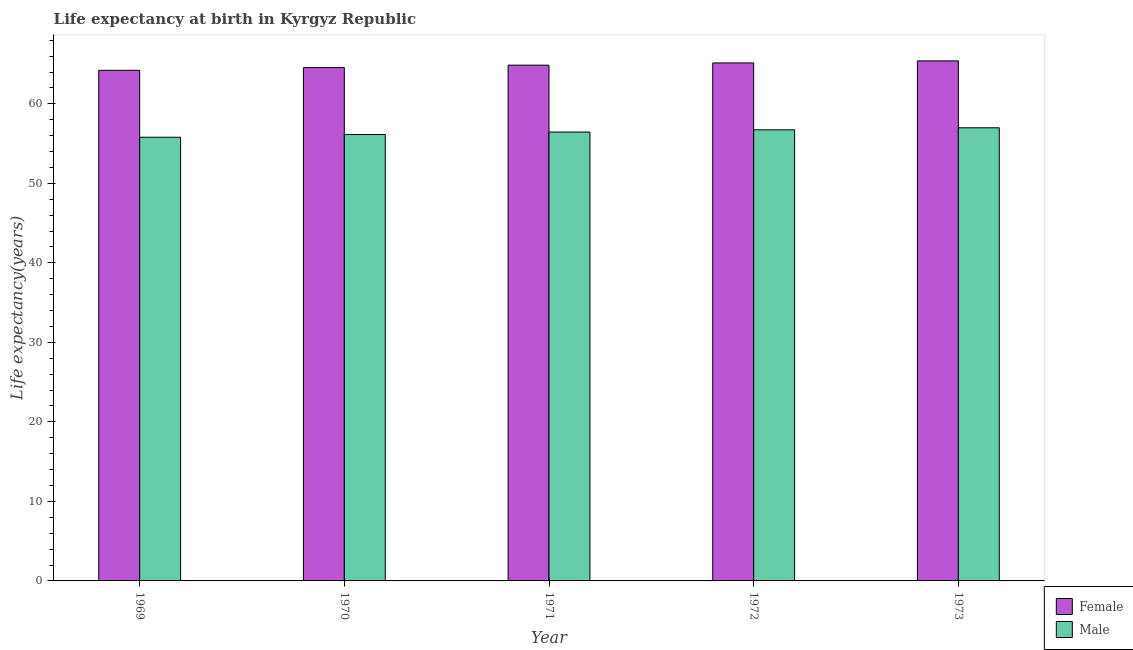Are the number of bars per tick equal to the number of legend labels?
Your response must be concise. Yes. How many bars are there on the 1st tick from the right?
Your answer should be compact. 2. What is the label of the 1st group of bars from the left?
Keep it short and to the point. 1969. What is the life expectancy(female) in 1969?
Offer a very short reply. 64.21. Across all years, what is the maximum life expectancy(male)?
Offer a very short reply. 56.99. Across all years, what is the minimum life expectancy(male)?
Make the answer very short. 55.8. In which year was the life expectancy(male) maximum?
Offer a very short reply. 1973. In which year was the life expectancy(male) minimum?
Provide a succinct answer. 1969. What is the total life expectancy(male) in the graph?
Offer a terse response. 282.11. What is the difference between the life expectancy(male) in 1971 and that in 1972?
Give a very brief answer. -0.28. What is the difference between the life expectancy(male) in 1971 and the life expectancy(female) in 1970?
Offer a very short reply. 0.31. What is the average life expectancy(female) per year?
Offer a terse response. 64.84. In the year 1973, what is the difference between the life expectancy(male) and life expectancy(female)?
Keep it short and to the point. 0. What is the ratio of the life expectancy(female) in 1971 to that in 1972?
Your answer should be very brief. 1. Is the life expectancy(male) in 1971 less than that in 1972?
Your answer should be very brief. Yes. What is the difference between the highest and the second highest life expectancy(female)?
Your answer should be very brief. 0.26. What is the difference between the highest and the lowest life expectancy(male)?
Provide a succinct answer. 1.19. Is the sum of the life expectancy(male) in 1969 and 1973 greater than the maximum life expectancy(female) across all years?
Provide a short and direct response. Yes. Are all the bars in the graph horizontal?
Your response must be concise. No. Does the graph contain grids?
Your answer should be compact. No. Where does the legend appear in the graph?
Ensure brevity in your answer.  Bottom right. How are the legend labels stacked?
Make the answer very short. Vertical. What is the title of the graph?
Offer a very short reply. Life expectancy at birth in Kyrgyz Republic. Does "Drinking water services" appear as one of the legend labels in the graph?
Provide a short and direct response. No. What is the label or title of the X-axis?
Your response must be concise. Year. What is the label or title of the Y-axis?
Your answer should be very brief. Life expectancy(years). What is the Life expectancy(years) in Female in 1969?
Your answer should be compact. 64.21. What is the Life expectancy(years) of Male in 1969?
Offer a terse response. 55.8. What is the Life expectancy(years) of Female in 1970?
Offer a very short reply. 64.55. What is the Life expectancy(years) in Male in 1970?
Your response must be concise. 56.14. What is the Life expectancy(years) in Female in 1971?
Offer a very short reply. 64.86. What is the Life expectancy(years) in Male in 1971?
Your response must be concise. 56.45. What is the Life expectancy(years) in Female in 1972?
Provide a succinct answer. 65.14. What is the Life expectancy(years) of Male in 1972?
Provide a succinct answer. 56.73. What is the Life expectancy(years) in Female in 1973?
Keep it short and to the point. 65.4. What is the Life expectancy(years) in Male in 1973?
Provide a succinct answer. 56.99. Across all years, what is the maximum Life expectancy(years) in Female?
Offer a terse response. 65.4. Across all years, what is the maximum Life expectancy(years) in Male?
Offer a very short reply. 56.99. Across all years, what is the minimum Life expectancy(years) in Female?
Offer a very short reply. 64.21. Across all years, what is the minimum Life expectancy(years) in Male?
Ensure brevity in your answer.  55.8. What is the total Life expectancy(years) of Female in the graph?
Keep it short and to the point. 324.18. What is the total Life expectancy(years) of Male in the graph?
Provide a short and direct response. 282.11. What is the difference between the Life expectancy(years) of Female in 1969 and that in 1970?
Make the answer very short. -0.34. What is the difference between the Life expectancy(years) in Male in 1969 and that in 1970?
Provide a succinct answer. -0.34. What is the difference between the Life expectancy(years) of Female in 1969 and that in 1971?
Your response must be concise. -0.65. What is the difference between the Life expectancy(years) of Male in 1969 and that in 1971?
Your answer should be very brief. -0.65. What is the difference between the Life expectancy(years) in Female in 1969 and that in 1972?
Ensure brevity in your answer.  -0.93. What is the difference between the Life expectancy(years) of Male in 1969 and that in 1972?
Offer a terse response. -0.93. What is the difference between the Life expectancy(years) in Female in 1969 and that in 1973?
Keep it short and to the point. -1.19. What is the difference between the Life expectancy(years) of Male in 1969 and that in 1973?
Your answer should be very brief. -1.19. What is the difference between the Life expectancy(years) of Female in 1970 and that in 1971?
Your response must be concise. -0.31. What is the difference between the Life expectancy(years) of Male in 1970 and that in 1971?
Your answer should be compact. -0.31. What is the difference between the Life expectancy(years) of Female in 1970 and that in 1972?
Offer a very short reply. -0.59. What is the difference between the Life expectancy(years) of Male in 1970 and that in 1972?
Give a very brief answer. -0.59. What is the difference between the Life expectancy(years) of Female in 1970 and that in 1973?
Ensure brevity in your answer.  -0.85. What is the difference between the Life expectancy(years) of Male in 1970 and that in 1973?
Make the answer very short. -0.85. What is the difference between the Life expectancy(years) in Female in 1971 and that in 1972?
Your answer should be very brief. -0.28. What is the difference between the Life expectancy(years) of Male in 1971 and that in 1972?
Give a very brief answer. -0.28. What is the difference between the Life expectancy(years) in Female in 1971 and that in 1973?
Provide a succinct answer. -0.54. What is the difference between the Life expectancy(years) in Male in 1971 and that in 1973?
Provide a succinct answer. -0.54. What is the difference between the Life expectancy(years) of Female in 1972 and that in 1973?
Your answer should be very brief. -0.26. What is the difference between the Life expectancy(years) of Male in 1972 and that in 1973?
Offer a very short reply. -0.26. What is the difference between the Life expectancy(years) of Female in 1969 and the Life expectancy(years) of Male in 1970?
Your answer should be compact. 8.07. What is the difference between the Life expectancy(years) in Female in 1969 and the Life expectancy(years) in Male in 1971?
Give a very brief answer. 7.76. What is the difference between the Life expectancy(years) of Female in 1969 and the Life expectancy(years) of Male in 1972?
Make the answer very short. 7.48. What is the difference between the Life expectancy(years) of Female in 1969 and the Life expectancy(years) of Male in 1973?
Provide a succinct answer. 7.22. What is the difference between the Life expectancy(years) of Female in 1970 and the Life expectancy(years) of Male in 1971?
Keep it short and to the point. 8.1. What is the difference between the Life expectancy(years) of Female in 1970 and the Life expectancy(years) of Male in 1972?
Make the answer very short. 7.82. What is the difference between the Life expectancy(years) of Female in 1970 and the Life expectancy(years) of Male in 1973?
Offer a terse response. 7.57. What is the difference between the Life expectancy(years) in Female in 1971 and the Life expectancy(years) in Male in 1972?
Your answer should be compact. 8.13. What is the difference between the Life expectancy(years) of Female in 1971 and the Life expectancy(years) of Male in 1973?
Offer a very short reply. 7.87. What is the difference between the Life expectancy(years) in Female in 1972 and the Life expectancy(years) in Male in 1973?
Offer a very short reply. 8.15. What is the average Life expectancy(years) of Female per year?
Offer a terse response. 64.84. What is the average Life expectancy(years) of Male per year?
Make the answer very short. 56.42. In the year 1969, what is the difference between the Life expectancy(years) in Female and Life expectancy(years) in Male?
Offer a very short reply. 8.41. In the year 1970, what is the difference between the Life expectancy(years) of Female and Life expectancy(years) of Male?
Provide a short and direct response. 8.41. In the year 1971, what is the difference between the Life expectancy(years) in Female and Life expectancy(years) in Male?
Your answer should be compact. 8.41. In the year 1972, what is the difference between the Life expectancy(years) of Female and Life expectancy(years) of Male?
Give a very brief answer. 8.41. In the year 1973, what is the difference between the Life expectancy(years) in Female and Life expectancy(years) in Male?
Your answer should be very brief. 8.41. What is the ratio of the Life expectancy(years) in Male in 1969 to that in 1970?
Your response must be concise. 0.99. What is the ratio of the Life expectancy(years) of Female in 1969 to that in 1971?
Your answer should be compact. 0.99. What is the ratio of the Life expectancy(years) in Female in 1969 to that in 1972?
Make the answer very short. 0.99. What is the ratio of the Life expectancy(years) in Male in 1969 to that in 1972?
Your response must be concise. 0.98. What is the ratio of the Life expectancy(years) of Female in 1969 to that in 1973?
Provide a short and direct response. 0.98. What is the ratio of the Life expectancy(years) in Male in 1969 to that in 1973?
Keep it short and to the point. 0.98. What is the ratio of the Life expectancy(years) of Male in 1970 to that in 1971?
Provide a succinct answer. 0.99. What is the ratio of the Life expectancy(years) in Female in 1970 to that in 1972?
Make the answer very short. 0.99. What is the ratio of the Life expectancy(years) in Female in 1970 to that in 1973?
Make the answer very short. 0.99. What is the ratio of the Life expectancy(years) in Male in 1970 to that in 1973?
Your answer should be compact. 0.99. What is the ratio of the Life expectancy(years) in Male in 1971 to that in 1972?
Offer a terse response. 0.99. What is the ratio of the Life expectancy(years) of Male in 1971 to that in 1973?
Offer a terse response. 0.99. What is the difference between the highest and the second highest Life expectancy(years) of Female?
Give a very brief answer. 0.26. What is the difference between the highest and the second highest Life expectancy(years) of Male?
Your answer should be compact. 0.26. What is the difference between the highest and the lowest Life expectancy(years) in Female?
Provide a succinct answer. 1.19. What is the difference between the highest and the lowest Life expectancy(years) of Male?
Provide a short and direct response. 1.19. 